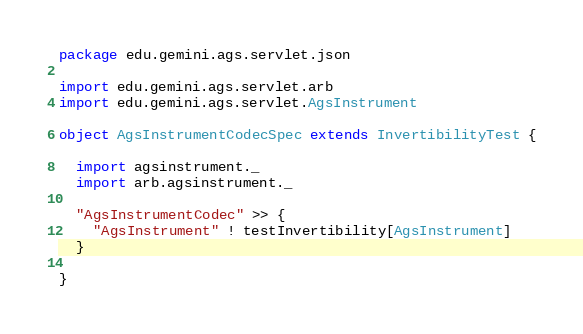<code> <loc_0><loc_0><loc_500><loc_500><_Scala_>package edu.gemini.ags.servlet.json

import edu.gemini.ags.servlet.arb
import edu.gemini.ags.servlet.AgsInstrument

object AgsInstrumentCodecSpec extends InvertibilityTest {

  import agsinstrument._
  import arb.agsinstrument._

  "AgsInstrumentCodec" >> {
    "AgsInstrument" ! testInvertibility[AgsInstrument]
  }

}
</code> 